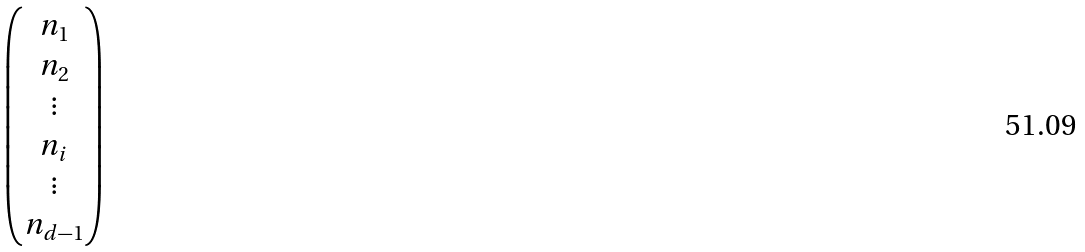<formula> <loc_0><loc_0><loc_500><loc_500>\begin{pmatrix} n _ { 1 } \\ n _ { 2 } \\ \vdots \\ n _ { i } \\ \vdots \\ n _ { d - 1 } \end{pmatrix}</formula> 